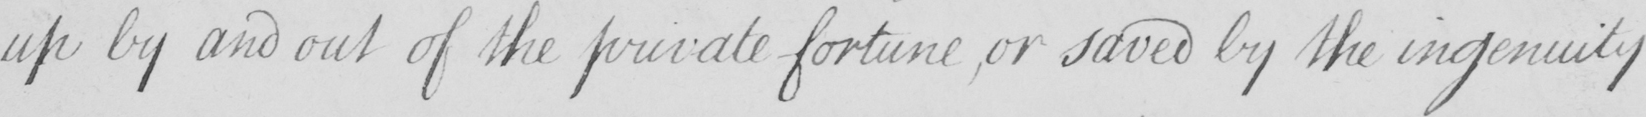What is written in this line of handwriting? up by and out of the private fortune ,or saved by the ingenuity 